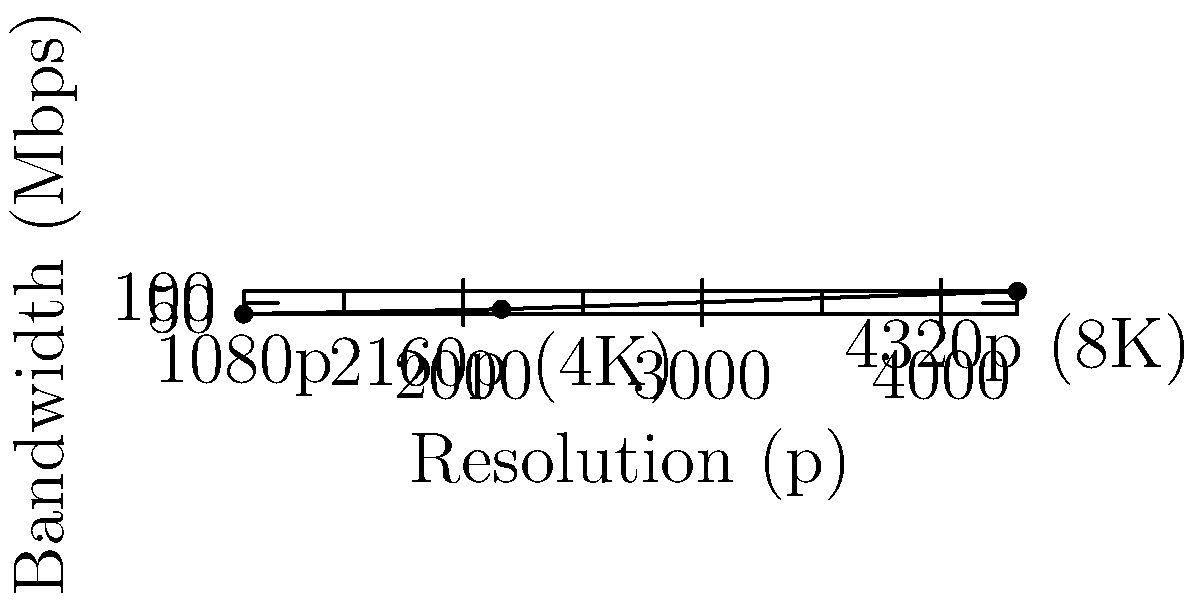Based on the graph illustrating bandwidth requirements for streaming high-quality cooking videos, what is the approximate bandwidth needed for streaming 4K (2160p) content? To determine the bandwidth required for streaming 4K content, we need to follow these steps:

1. Identify 4K resolution on the x-axis:
   4K resolution is equivalent to 2160p.

2. Locate the corresponding point on the graph:
   Find the point on the curve that aligns with 2160p on the x-axis.

3. Read the y-axis value for this point:
   The y-axis represents the bandwidth in Mbps (Megabits per second).

4. Interpret the result:
   The graph shows that for 2160p (4K) resolution, the bandwidth requirement is approximately 25 Mbps.

This bandwidth requirement ensures smooth streaming of high-quality 4K cooking videos, which is essential for showcasing the details and performance of luxury kitchen appliances to potential customers.
Answer: 25 Mbps 